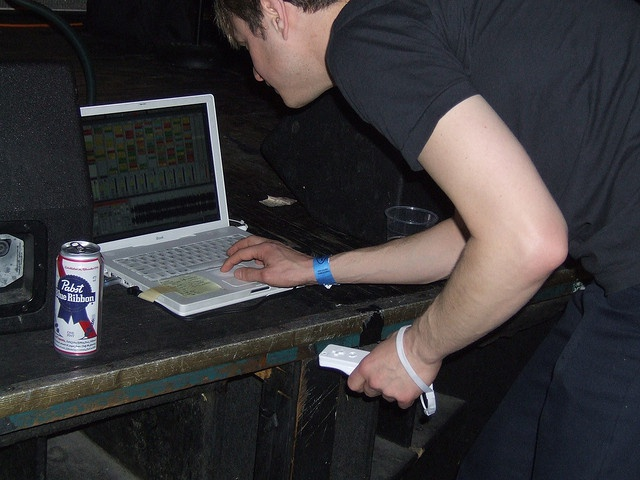Describe the objects in this image and their specific colors. I can see people in black, darkgray, tan, and gray tones, laptop in black, gray, and darkgray tones, cup in black and gray tones, and remote in black, lavender, lightgray, and darkgray tones in this image. 